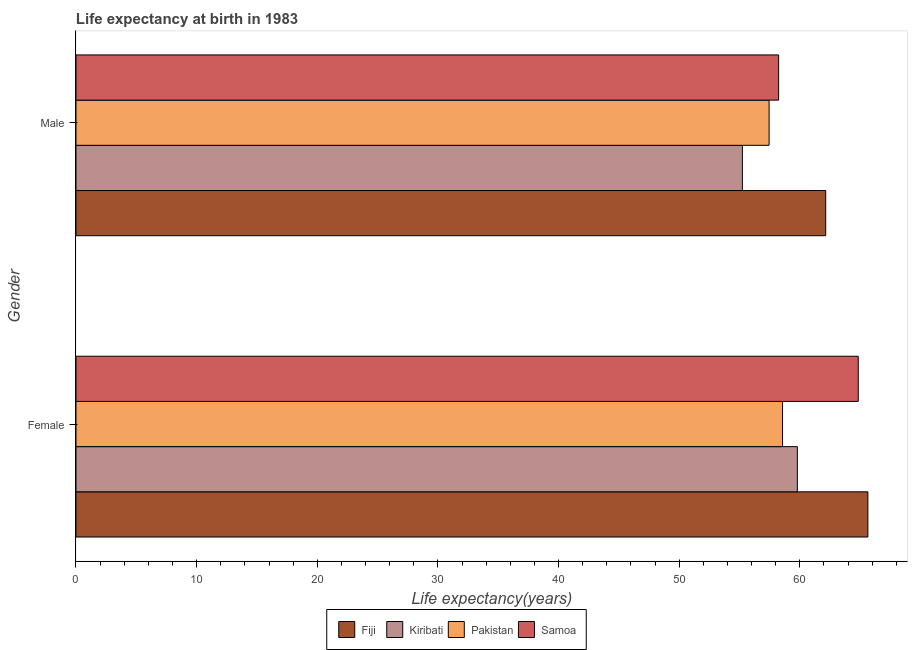How many groups of bars are there?
Keep it short and to the point. 2. Are the number of bars on each tick of the Y-axis equal?
Make the answer very short. Yes. What is the life expectancy(male) in Pakistan?
Offer a very short reply. 57.45. Across all countries, what is the maximum life expectancy(female)?
Ensure brevity in your answer.  65.64. Across all countries, what is the minimum life expectancy(female)?
Make the answer very short. 58.57. In which country was the life expectancy(male) maximum?
Offer a terse response. Fiji. In which country was the life expectancy(female) minimum?
Keep it short and to the point. Pakistan. What is the total life expectancy(male) in the graph?
Provide a succinct answer. 233.09. What is the difference between the life expectancy(female) in Fiji and that in Pakistan?
Ensure brevity in your answer.  7.08. What is the difference between the life expectancy(male) in Kiribati and the life expectancy(female) in Fiji?
Provide a short and direct response. -10.4. What is the average life expectancy(male) per country?
Your answer should be compact. 58.27. What is the difference between the life expectancy(male) and life expectancy(female) in Fiji?
Ensure brevity in your answer.  -3.5. What is the ratio of the life expectancy(female) in Samoa to that in Fiji?
Make the answer very short. 0.99. What does the 3rd bar from the top in Male represents?
Make the answer very short. Kiribati. What does the 2nd bar from the bottom in Female represents?
Offer a very short reply. Kiribati. How many countries are there in the graph?
Give a very brief answer. 4. What is the difference between two consecutive major ticks on the X-axis?
Keep it short and to the point. 10. Does the graph contain any zero values?
Give a very brief answer. No. Does the graph contain grids?
Give a very brief answer. No. How many legend labels are there?
Ensure brevity in your answer.  4. What is the title of the graph?
Your answer should be compact. Life expectancy at birth in 1983. Does "United Kingdom" appear as one of the legend labels in the graph?
Ensure brevity in your answer.  No. What is the label or title of the X-axis?
Keep it short and to the point. Life expectancy(years). What is the label or title of the Y-axis?
Your answer should be very brief. Gender. What is the Life expectancy(years) of Fiji in Female?
Keep it short and to the point. 65.64. What is the Life expectancy(years) of Kiribati in Female?
Offer a very short reply. 59.8. What is the Life expectancy(years) in Pakistan in Female?
Offer a very short reply. 58.57. What is the Life expectancy(years) in Samoa in Female?
Make the answer very short. 64.84. What is the Life expectancy(years) of Fiji in Male?
Provide a short and direct response. 62.15. What is the Life expectancy(years) in Kiribati in Male?
Offer a terse response. 55.24. What is the Life expectancy(years) in Pakistan in Male?
Your answer should be very brief. 57.45. What is the Life expectancy(years) of Samoa in Male?
Provide a succinct answer. 58.24. Across all Gender, what is the maximum Life expectancy(years) in Fiji?
Your answer should be very brief. 65.64. Across all Gender, what is the maximum Life expectancy(years) of Kiribati?
Offer a very short reply. 59.8. Across all Gender, what is the maximum Life expectancy(years) in Pakistan?
Your answer should be compact. 58.57. Across all Gender, what is the maximum Life expectancy(years) of Samoa?
Your answer should be compact. 64.84. Across all Gender, what is the minimum Life expectancy(years) of Fiji?
Keep it short and to the point. 62.15. Across all Gender, what is the minimum Life expectancy(years) of Kiribati?
Your response must be concise. 55.24. Across all Gender, what is the minimum Life expectancy(years) in Pakistan?
Offer a terse response. 57.45. Across all Gender, what is the minimum Life expectancy(years) in Samoa?
Provide a succinct answer. 58.24. What is the total Life expectancy(years) in Fiji in the graph?
Your response must be concise. 127.79. What is the total Life expectancy(years) in Kiribati in the graph?
Provide a short and direct response. 115.04. What is the total Life expectancy(years) of Pakistan in the graph?
Offer a terse response. 116.02. What is the total Life expectancy(years) of Samoa in the graph?
Your answer should be very brief. 123.09. What is the difference between the Life expectancy(years) in Fiji in Female and that in Male?
Keep it short and to the point. 3.5. What is the difference between the Life expectancy(years) in Kiribati in Female and that in Male?
Provide a succinct answer. 4.56. What is the difference between the Life expectancy(years) in Pakistan in Female and that in Male?
Keep it short and to the point. 1.11. What is the difference between the Life expectancy(years) in Fiji in Female and the Life expectancy(years) in Kiribati in Male?
Your answer should be compact. 10.4. What is the difference between the Life expectancy(years) of Fiji in Female and the Life expectancy(years) of Pakistan in Male?
Make the answer very short. 8.19. What is the difference between the Life expectancy(years) of Kiribati in Female and the Life expectancy(years) of Pakistan in Male?
Ensure brevity in your answer.  2.34. What is the difference between the Life expectancy(years) of Kiribati in Female and the Life expectancy(years) of Samoa in Male?
Your response must be concise. 1.55. What is the difference between the Life expectancy(years) of Pakistan in Female and the Life expectancy(years) of Samoa in Male?
Offer a very short reply. 0.32. What is the average Life expectancy(years) in Fiji per Gender?
Keep it short and to the point. 63.9. What is the average Life expectancy(years) in Kiribati per Gender?
Your answer should be compact. 57.52. What is the average Life expectancy(years) of Pakistan per Gender?
Provide a succinct answer. 58.01. What is the average Life expectancy(years) of Samoa per Gender?
Ensure brevity in your answer.  61.55. What is the difference between the Life expectancy(years) in Fiji and Life expectancy(years) in Kiribati in Female?
Offer a terse response. 5.85. What is the difference between the Life expectancy(years) in Fiji and Life expectancy(years) in Pakistan in Female?
Offer a terse response. 7.08. What is the difference between the Life expectancy(years) in Fiji and Life expectancy(years) in Samoa in Female?
Your answer should be compact. 0.8. What is the difference between the Life expectancy(years) in Kiribati and Life expectancy(years) in Pakistan in Female?
Your answer should be very brief. 1.23. What is the difference between the Life expectancy(years) of Kiribati and Life expectancy(years) of Samoa in Female?
Offer a terse response. -5.05. What is the difference between the Life expectancy(years) in Pakistan and Life expectancy(years) in Samoa in Female?
Your response must be concise. -6.28. What is the difference between the Life expectancy(years) of Fiji and Life expectancy(years) of Kiribati in Male?
Offer a very short reply. 6.91. What is the difference between the Life expectancy(years) of Fiji and Life expectancy(years) of Pakistan in Male?
Make the answer very short. 4.69. What is the difference between the Life expectancy(years) in Fiji and Life expectancy(years) in Samoa in Male?
Keep it short and to the point. 3.9. What is the difference between the Life expectancy(years) in Kiribati and Life expectancy(years) in Pakistan in Male?
Your answer should be compact. -2.21. What is the difference between the Life expectancy(years) of Kiribati and Life expectancy(years) of Samoa in Male?
Offer a very short reply. -3. What is the difference between the Life expectancy(years) of Pakistan and Life expectancy(years) of Samoa in Male?
Keep it short and to the point. -0.79. What is the ratio of the Life expectancy(years) of Fiji in Female to that in Male?
Your response must be concise. 1.06. What is the ratio of the Life expectancy(years) of Kiribati in Female to that in Male?
Give a very brief answer. 1.08. What is the ratio of the Life expectancy(years) in Pakistan in Female to that in Male?
Keep it short and to the point. 1.02. What is the ratio of the Life expectancy(years) in Samoa in Female to that in Male?
Your response must be concise. 1.11. What is the difference between the highest and the second highest Life expectancy(years) of Fiji?
Keep it short and to the point. 3.5. What is the difference between the highest and the second highest Life expectancy(years) in Kiribati?
Your answer should be very brief. 4.56. What is the difference between the highest and the second highest Life expectancy(years) of Pakistan?
Keep it short and to the point. 1.11. What is the difference between the highest and the second highest Life expectancy(years) of Samoa?
Your answer should be compact. 6.6. What is the difference between the highest and the lowest Life expectancy(years) of Fiji?
Ensure brevity in your answer.  3.5. What is the difference between the highest and the lowest Life expectancy(years) in Kiribati?
Keep it short and to the point. 4.56. What is the difference between the highest and the lowest Life expectancy(years) in Pakistan?
Provide a short and direct response. 1.11. 